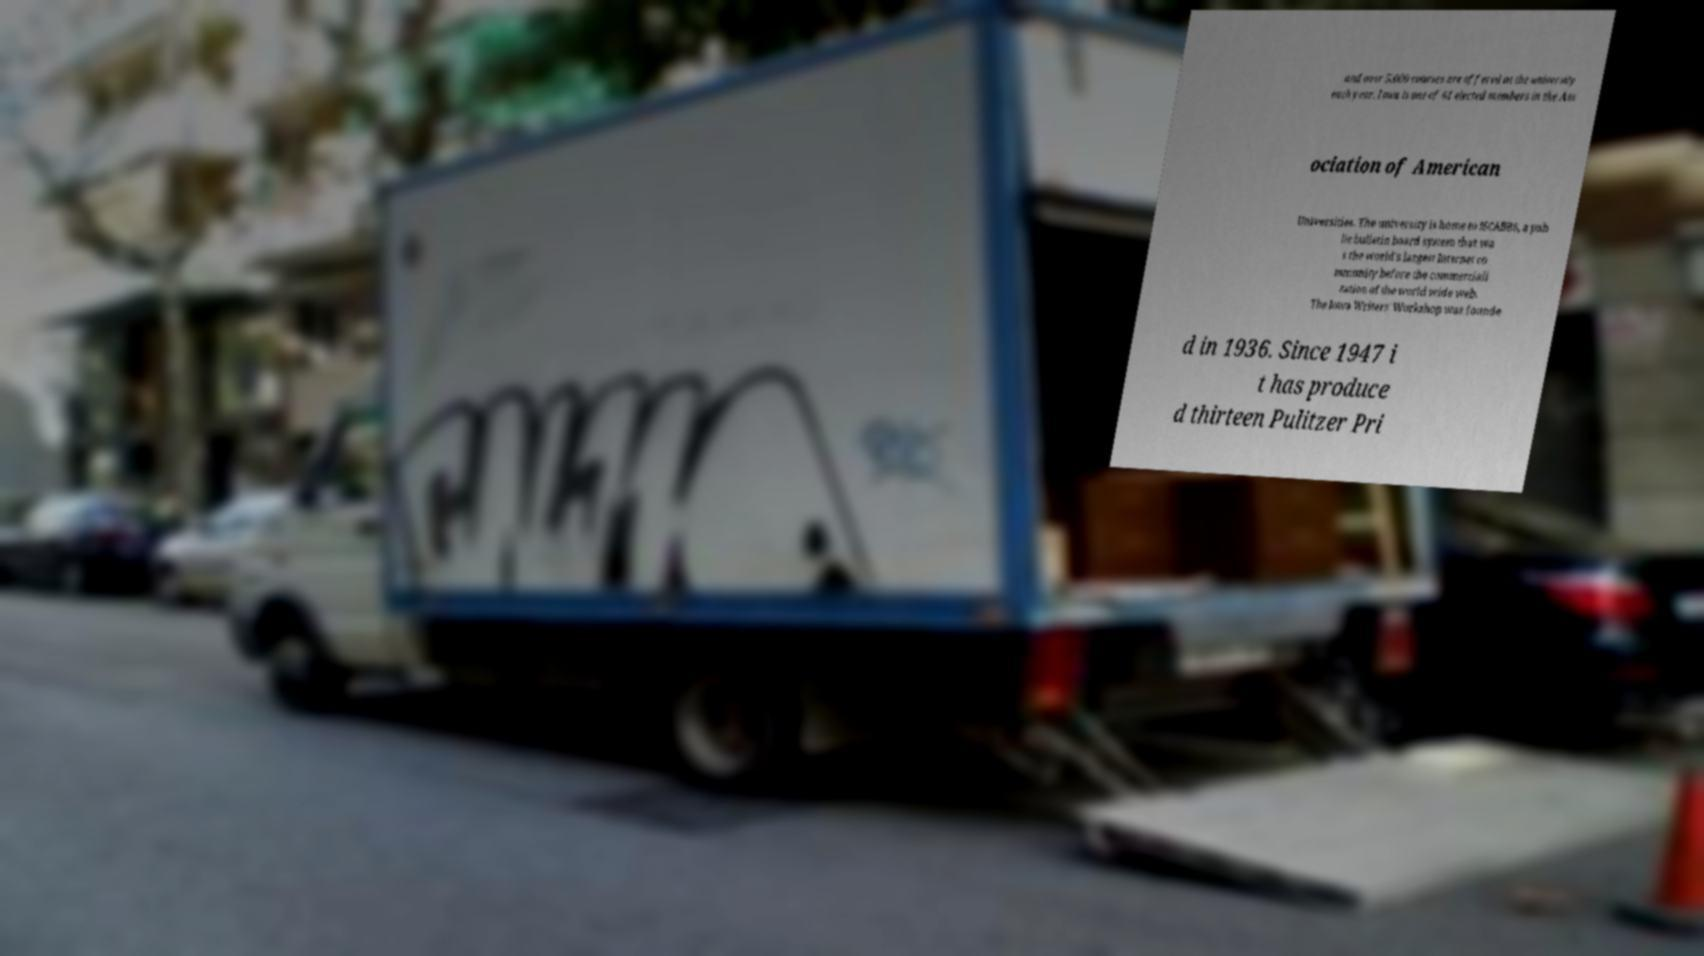Can you accurately transcribe the text from the provided image for me? and over 5,000 courses are offered at the university each year. Iowa is one of 61 elected members in the Ass ociation of American Universities. The university is home to ISCABBS, a pub lic bulletin board system that wa s the world's largest Internet co mmunity before the commerciali zation of the world wide web. The Iowa Writers' Workshop was founde d in 1936. Since 1947 i t has produce d thirteen Pulitzer Pri 